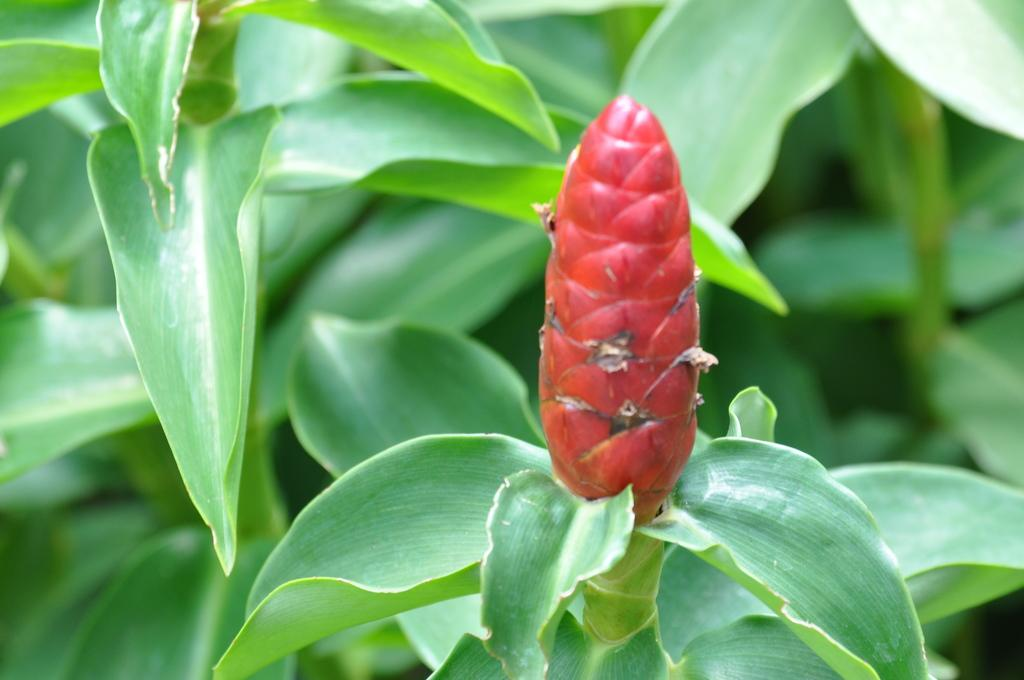What color are the buds in the image? The buds in the image are red. What color are the leaves in the image? The leaves in the image are green. What type of meal can be smelled in the image? There is no meal present in the image, and therefore no smell can be detected. What adjustment can be made to the leaves in the image? There is no need to adjust the leaves in the image, as they are already part of the plant. 